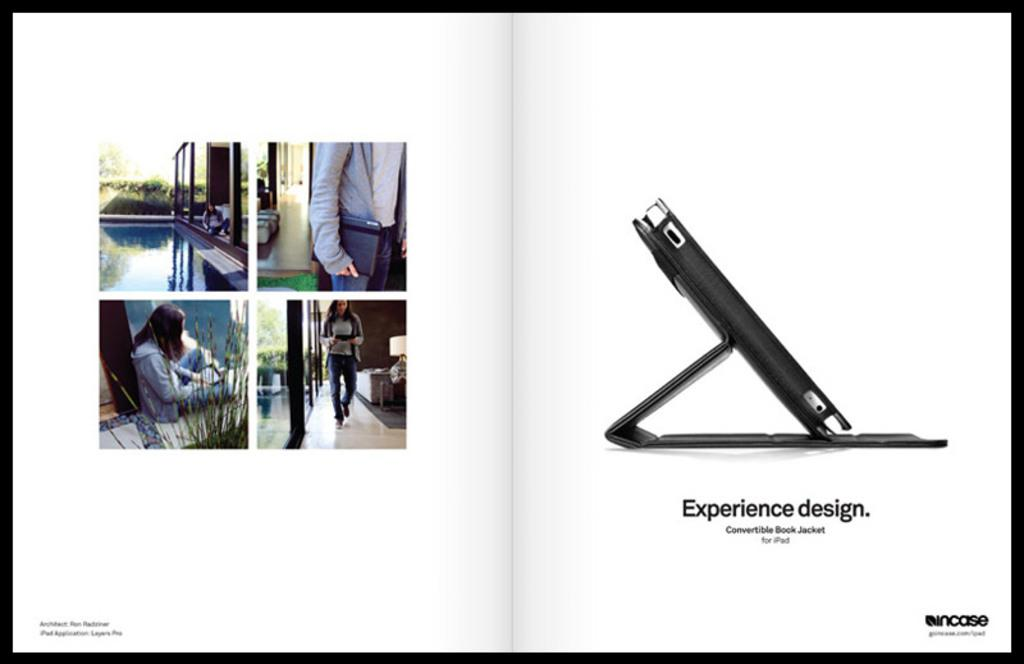How many people are in the image? There are people in the image, but the exact number is not specified. What is the primary setting of the image? The image features water, a building, and plants, suggesting an outdoor or waterfront location. What object is present with the people in the image? There is a mobile phone with a cover case in the image. What is written at the bottom of the image? There is some text at the bottom of the image, but its content is not specified. What type of guide is being used to twist a spade in the image? There is no guide, twist, or spade present in the image. 